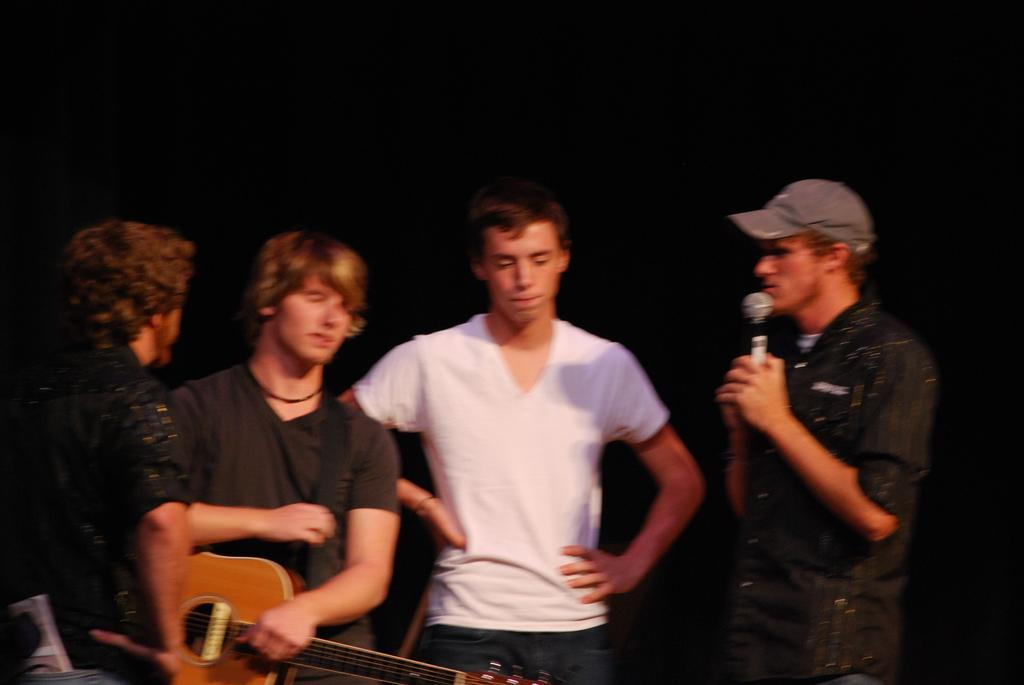How many people are present in the image? There are four people in the image. What are the people doing in the image? The people are talking with each other. Can you describe the man on the right side of the image? The man on the right side of the image is holding a mic. What is the man on the left side of the image holding? The man on the left side of the image is holding a guitar. What type of cracker is being passed around in the image? There is no cracker present in the image. Can you describe the trees in the background of the image? There are no trees visible in the image. 